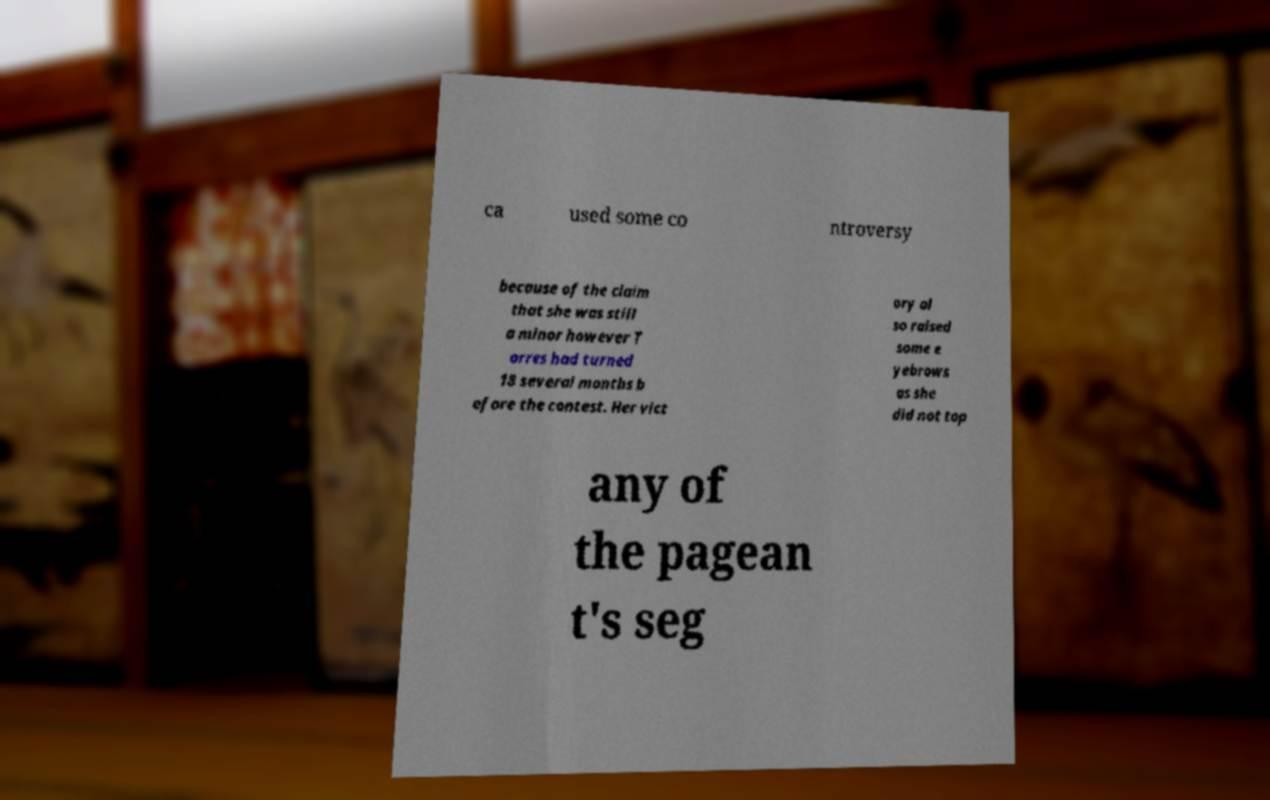Please read and relay the text visible in this image. What does it say? ca used some co ntroversy because of the claim that she was still a minor however T orres had turned 18 several months b efore the contest. Her vict ory al so raised some e yebrows as she did not top any of the pagean t's seg 